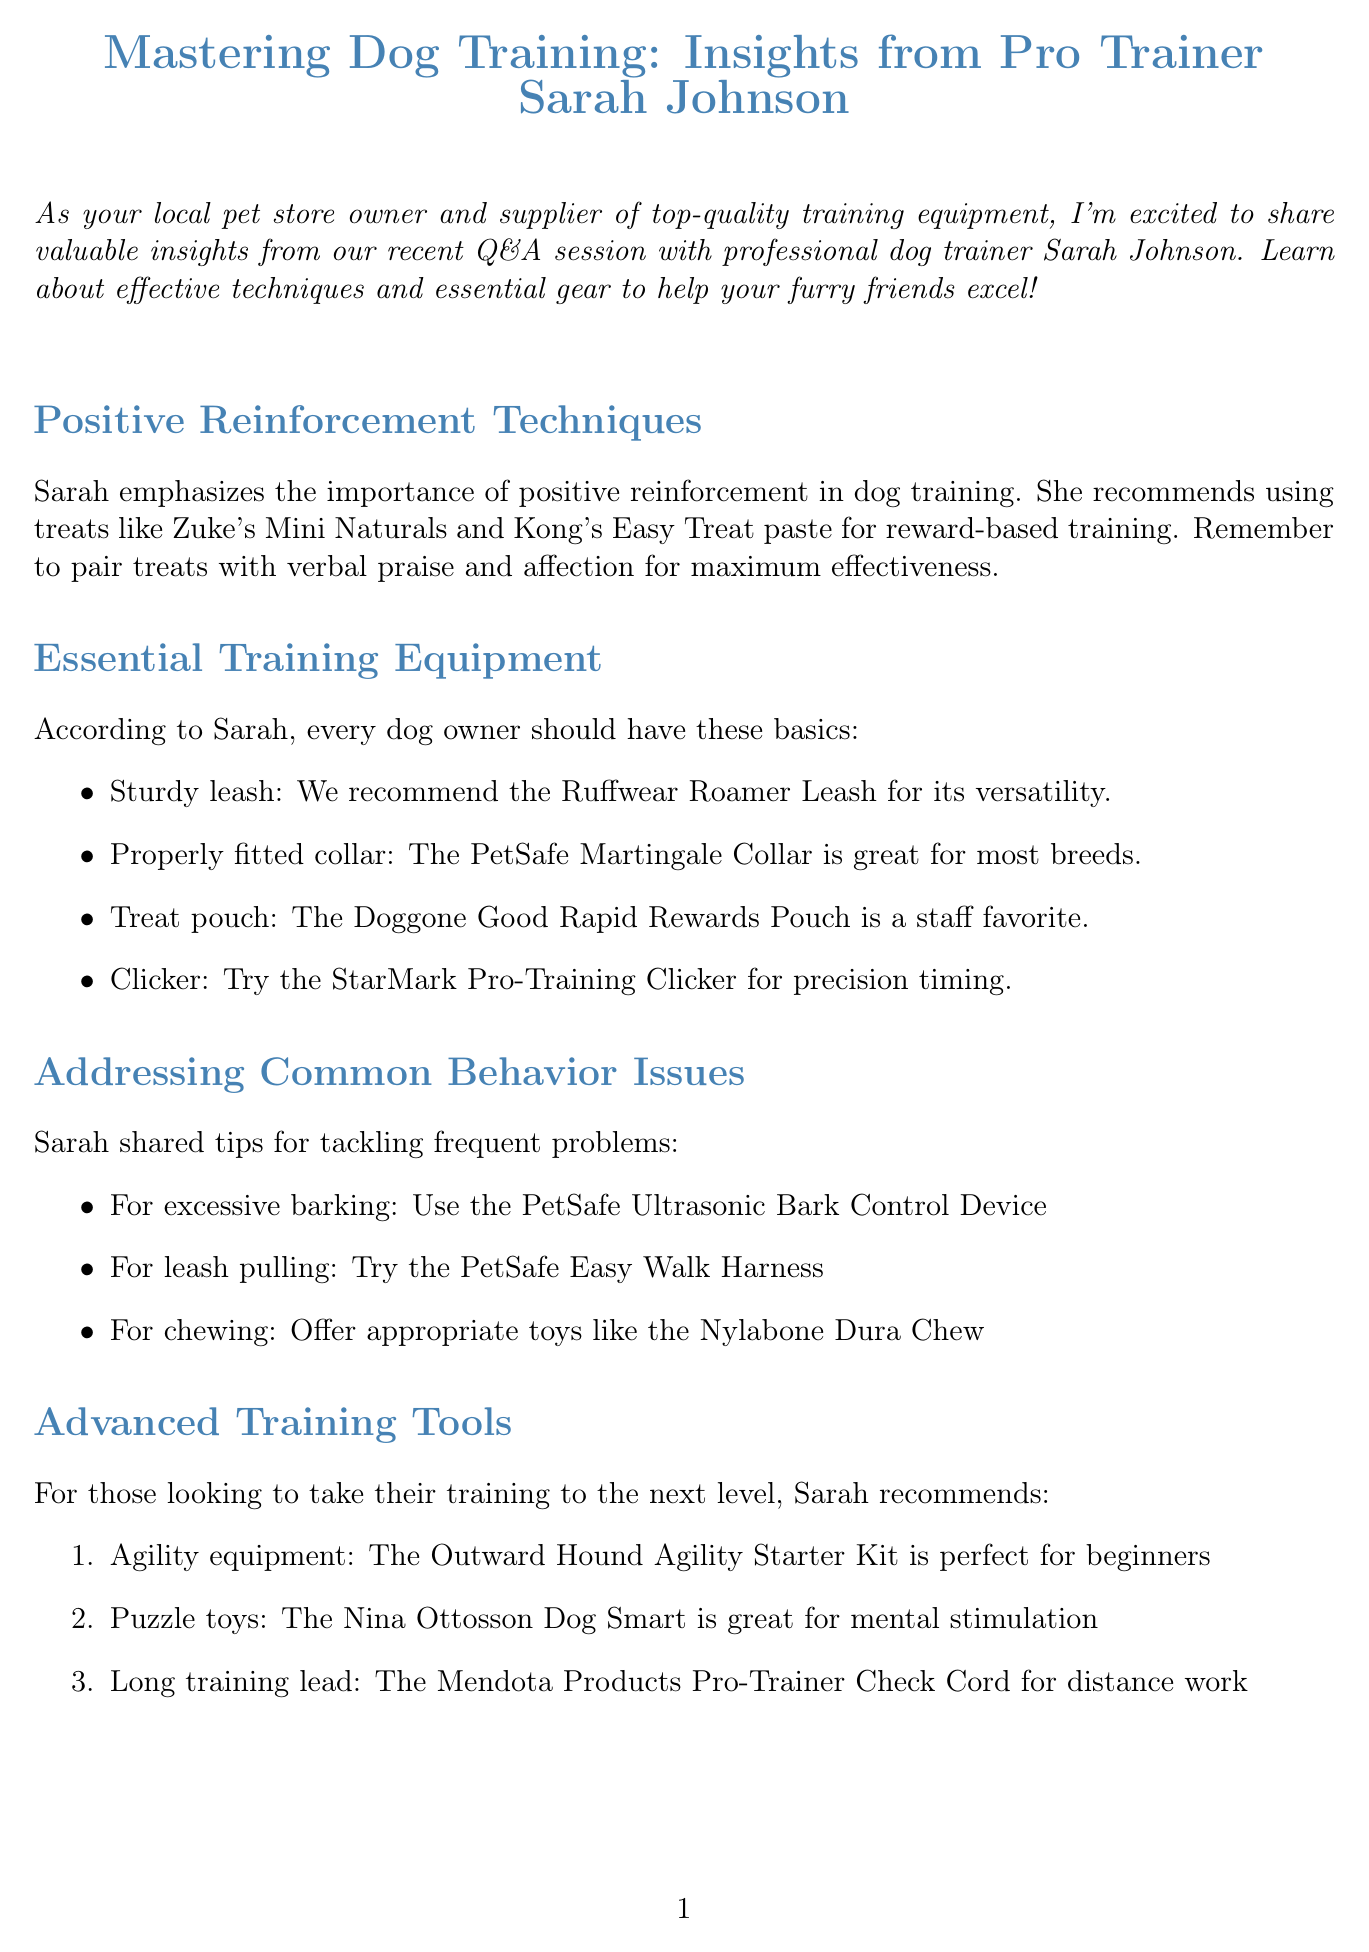What is the title of the newsletter? The title of the newsletter is explicitly stated at the beginning of the document.
Answer: Mastering Dog Training: Insights from Pro Trainer Sarah Johnson Who is the expert featured in the Q&A session? The document mentions the name of the professional dog trainer who provided insights.
Answer: Sarah Johnson What type of training does Sarah Johnson specialize in? The document provides information about the expert's specialization in dog training.
Answer: Positive reinforcement techniques What is one recommended treat for training? The document lists specific treats recommended by Sarah for positive reinforcement training.
Answer: Zuke's Mini Naturals What is the purpose of using a clicker in training? The document provides insight into the use of a clicker as suggested by Sarah.
Answer: Precision timing Which product is recommended for leash pulling? The document includes a solution to a common behavior issue related to leash pulling.
Answer: PetSafe Easy Walk Harness What basic equipment is a treat pouch classified as? The document categorizes certain items as essential training equipment for dog owners.
Answer: Essential training equipment What is one advanced training tool recommended for beginners? The document specifies advanced training recommendations suitable for beginners.
Answer: Outward Hound Agility Starter Kit Where is Pawsome Pet Supplies located? The document includes the address of the local pet store.
Answer: 123 Main Street, Anytown, USA 